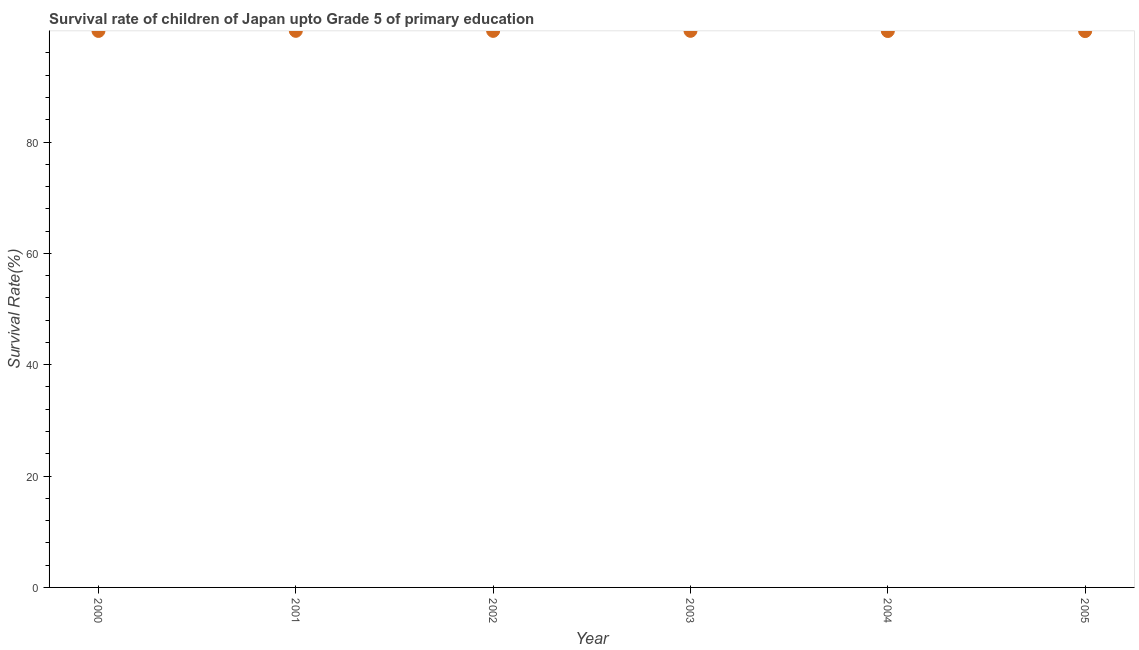What is the survival rate in 2001?
Keep it short and to the point. 99.97. Across all years, what is the maximum survival rate?
Provide a short and direct response. 99.97. Across all years, what is the minimum survival rate?
Your response must be concise. 99.92. In which year was the survival rate maximum?
Provide a short and direct response. 2003. What is the sum of the survival rate?
Your response must be concise. 599.71. What is the difference between the survival rate in 2001 and 2005?
Offer a terse response. 0.04. What is the average survival rate per year?
Give a very brief answer. 99.95. What is the median survival rate?
Give a very brief answer. 99.96. What is the ratio of the survival rate in 2003 to that in 2005?
Your response must be concise. 1. Is the survival rate in 2003 less than that in 2004?
Make the answer very short. No. What is the difference between the highest and the second highest survival rate?
Keep it short and to the point. 0. Is the sum of the survival rate in 2004 and 2005 greater than the maximum survival rate across all years?
Provide a short and direct response. Yes. What is the difference between the highest and the lowest survival rate?
Offer a very short reply. 0.04. In how many years, is the survival rate greater than the average survival rate taken over all years?
Provide a short and direct response. 4. Does the survival rate monotonically increase over the years?
Ensure brevity in your answer.  No. How many years are there in the graph?
Provide a succinct answer. 6. What is the difference between two consecutive major ticks on the Y-axis?
Your answer should be compact. 20. Does the graph contain any zero values?
Provide a short and direct response. No. What is the title of the graph?
Provide a succinct answer. Survival rate of children of Japan upto Grade 5 of primary education. What is the label or title of the Y-axis?
Provide a short and direct response. Survival Rate(%). What is the Survival Rate(%) in 2000?
Your answer should be compact. 99.95. What is the Survival Rate(%) in 2001?
Your answer should be very brief. 99.97. What is the Survival Rate(%) in 2002?
Ensure brevity in your answer.  99.96. What is the Survival Rate(%) in 2003?
Your answer should be compact. 99.97. What is the Survival Rate(%) in 2004?
Give a very brief answer. 99.94. What is the Survival Rate(%) in 2005?
Give a very brief answer. 99.92. What is the difference between the Survival Rate(%) in 2000 and 2001?
Your answer should be compact. -0.02. What is the difference between the Survival Rate(%) in 2000 and 2002?
Your answer should be very brief. -0.01. What is the difference between the Survival Rate(%) in 2000 and 2003?
Keep it short and to the point. -0.02. What is the difference between the Survival Rate(%) in 2000 and 2004?
Offer a very short reply. 0.02. What is the difference between the Survival Rate(%) in 2000 and 2005?
Your answer should be very brief. 0.03. What is the difference between the Survival Rate(%) in 2001 and 2002?
Your answer should be very brief. 0.01. What is the difference between the Survival Rate(%) in 2001 and 2003?
Make the answer very short. -0. What is the difference between the Survival Rate(%) in 2001 and 2004?
Provide a succinct answer. 0.03. What is the difference between the Survival Rate(%) in 2001 and 2005?
Provide a succinct answer. 0.04. What is the difference between the Survival Rate(%) in 2002 and 2003?
Offer a very short reply. -0.01. What is the difference between the Survival Rate(%) in 2002 and 2004?
Offer a terse response. 0.02. What is the difference between the Survival Rate(%) in 2002 and 2005?
Keep it short and to the point. 0.04. What is the difference between the Survival Rate(%) in 2003 and 2004?
Offer a very short reply. 0.03. What is the difference between the Survival Rate(%) in 2003 and 2005?
Give a very brief answer. 0.04. What is the difference between the Survival Rate(%) in 2004 and 2005?
Your answer should be very brief. 0.01. What is the ratio of the Survival Rate(%) in 2000 to that in 2001?
Your answer should be compact. 1. What is the ratio of the Survival Rate(%) in 2000 to that in 2002?
Offer a very short reply. 1. What is the ratio of the Survival Rate(%) in 2000 to that in 2003?
Offer a terse response. 1. What is the ratio of the Survival Rate(%) in 2000 to that in 2005?
Your response must be concise. 1. What is the ratio of the Survival Rate(%) in 2001 to that in 2003?
Make the answer very short. 1. What is the ratio of the Survival Rate(%) in 2001 to that in 2004?
Your response must be concise. 1. What is the ratio of the Survival Rate(%) in 2003 to that in 2004?
Your answer should be compact. 1. What is the ratio of the Survival Rate(%) in 2003 to that in 2005?
Make the answer very short. 1. 